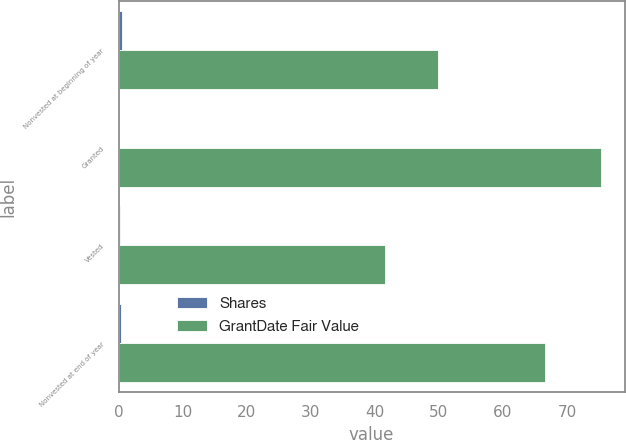Convert chart. <chart><loc_0><loc_0><loc_500><loc_500><stacked_bar_chart><ecel><fcel>Nonvested at beginning of year<fcel>Granted<fcel>Vested<fcel>Nonvested at end of year<nl><fcel>Shares<fcel>0.6<fcel>0.1<fcel>0.3<fcel>0.4<nl><fcel>GrantDate Fair Value<fcel>49.91<fcel>75.27<fcel>41.59<fcel>66.55<nl></chart> 